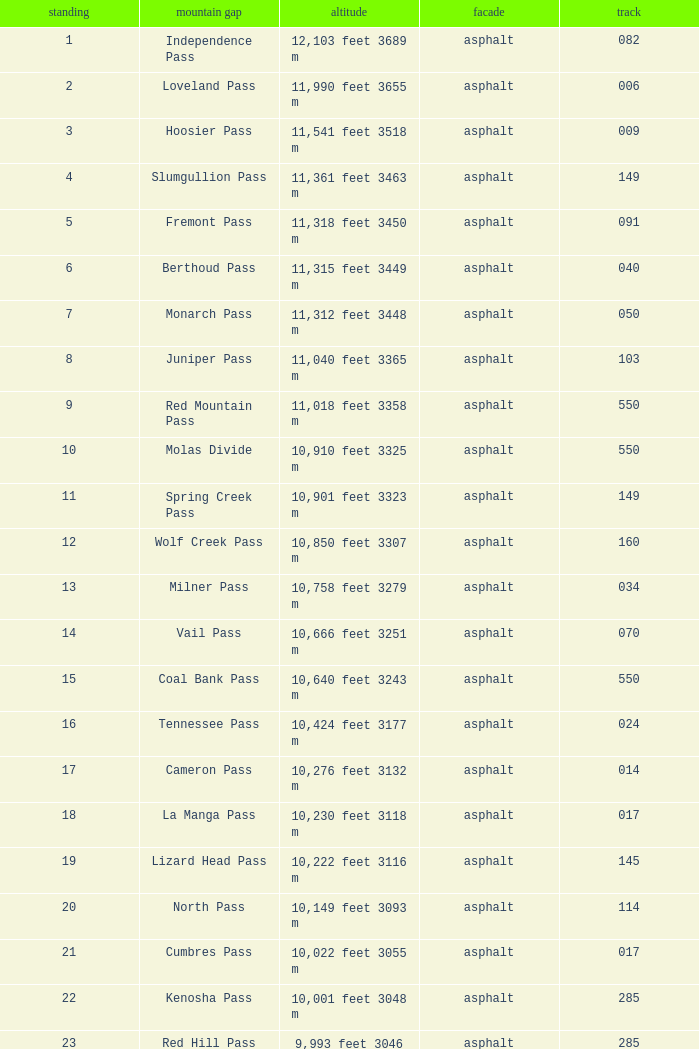Help me parse the entirety of this table. {'header': ['standing', 'mountain gap', 'altitude', 'facade', 'track'], 'rows': [['1', 'Independence Pass', '12,103 feet 3689 m', 'asphalt', '082'], ['2', 'Loveland Pass', '11,990 feet 3655 m', 'asphalt', '006'], ['3', 'Hoosier Pass', '11,541 feet 3518 m', 'asphalt', '009'], ['4', 'Slumgullion Pass', '11,361 feet 3463 m', 'asphalt', '149'], ['5', 'Fremont Pass', '11,318 feet 3450 m', 'asphalt', '091'], ['6', 'Berthoud Pass', '11,315 feet 3449 m', 'asphalt', '040'], ['7', 'Monarch Pass', '11,312 feet 3448 m', 'asphalt', '050'], ['8', 'Juniper Pass', '11,040 feet 3365 m', 'asphalt', '103'], ['9', 'Red Mountain Pass', '11,018 feet 3358 m', 'asphalt', '550'], ['10', 'Molas Divide', '10,910 feet 3325 m', 'asphalt', '550'], ['11', 'Spring Creek Pass', '10,901 feet 3323 m', 'asphalt', '149'], ['12', 'Wolf Creek Pass', '10,850 feet 3307 m', 'asphalt', '160'], ['13', 'Milner Pass', '10,758 feet 3279 m', 'asphalt', '034'], ['14', 'Vail Pass', '10,666 feet 3251 m', 'asphalt', '070'], ['15', 'Coal Bank Pass', '10,640 feet 3243 m', 'asphalt', '550'], ['16', 'Tennessee Pass', '10,424 feet 3177 m', 'asphalt', '024'], ['17', 'Cameron Pass', '10,276 feet 3132 m', 'asphalt', '014'], ['18', 'La Manga Pass', '10,230 feet 3118 m', 'asphalt', '017'], ['19', 'Lizard Head Pass', '10,222 feet 3116 m', 'asphalt', '145'], ['20', 'North Pass', '10,149 feet 3093 m', 'asphalt', '114'], ['21', 'Cumbres Pass', '10,022 feet 3055 m', 'asphalt', '017'], ['22', 'Kenosha Pass', '10,001 feet 3048 m', 'asphalt', '285'], ['23', 'Red Hill Pass', '9,993 feet 3046 m', 'asphalt', '285'], ['24', 'Cucharas Pass', '9,941 feet 3030 m', 'asphalt', '012'], ['25', 'Willow Creek Pass', '9,621 feet 2932 m', 'asphalt', '125'], ['26', 'Gore Pass', '9,527 feet 2904 m', 'asphalt', '134'], ['27', 'Wilkerson Pass', '9,507 feet 2898 m', 'asphalt', '024'], ['28', 'Currant Creek Pass', '9,482 feet 2890 m', 'asphalt', '009'], ['29', 'Rabbit Ears Pass', '9,426 feet 2873 m', 'asphalt', '040'], ['30', 'North La Veta Pass', '9,413 feet 2869 m', 'asphalt', '160'], ['31', 'Trout Creek Pass', '9,346 feet 2849 m', 'asphalt', '024.285'], ['32', 'Ute Pass', '9,165 feet 2793 m', 'asphalt', '024'], ['33', 'Wind River Pass', '9,150 feet 2790 m', 'asphalt', '007'], ['34', 'Hardscrabble Pass', '9,085 feet 2769 m', 'asphalt', '096'], ['35', 'Poncha Pass', '9,010 feet 2746 m', 'asphalt', '285'], ['36', 'Dallas Divide', '8,970 feet 2734 m', 'asphalt', '062'], ['37', 'Muddy Pass', '8,772 feet 2674 m', 'asphalt', '040'], ['38', 'McClure Pass', '8,755 feet 2669 m', 'asphalt', '133'], ['39', 'Douglas Pass', '8,268 feet 2520 m', 'asphalt', '139'], ['40', 'Cerro Summit', '7,958 feet 2423 m', 'asphalt', '050'], ['41', 'Raton Pass', '7,834 feet 2388 m', 'asphalt', '025'], ['42', 'Yellowjacket Pass', '7,783 feet 2372 m', 'asphalt', '160'], ['43', 'Monument Hill', '7,343 feet 2238 m', 'asphalt', '025'], ['44', 'Unaweep Divide', '7,048 feet 2148 m', 'asphalt', '141']]} What Mountain Pass has an Elevation of 10,001 feet 3048 m? Kenosha Pass. 